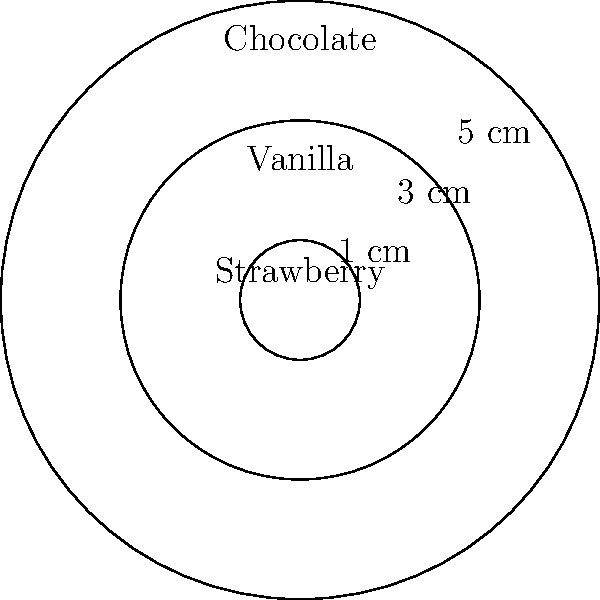You're designing a circular cake with three concentric rings of different flavors for a client's birthday party. The outer ring is chocolate, the middle ring is vanilla, and the center is strawberry. The cake has a total radius of 5 cm, with the vanilla ring starting at 3 cm from the center, and the strawberry center having a radius of 1 cm. What is the difference in area between the chocolate and vanilla sections of the cake? Let's approach this step-by-step:

1) First, we need to calculate the areas of the different sections:

   Chocolate section: Area of 5 cm circle minus area of 3 cm circle
   Vanilla section: Area of 3 cm circle minus area of 1 cm circle
   Strawberry section: Area of 1 cm circle

2) The formula for the area of a circle is $A = \pi r^2$

3) Let's calculate each area:

   Total cake area: $A_1 = \pi (5^2) = 25\pi$ cm²
   Area up to vanilla: $A_2 = \pi (3^2) = 9\pi$ cm²
   Strawberry area: $A_3 = \pi (1^2) = \pi$ cm²

4) Now we can calculate the areas of chocolate and vanilla sections:

   Chocolate area: $A_1 - A_2 = 25\pi - 9\pi = 16\pi$ cm²
   Vanilla area: $A_2 - A_3 = 9\pi - \pi = 8\pi$ cm²

5) The difference in area is:

   $16\pi - 8\pi = 8\pi$ cm²

Therefore, the chocolate section is $8\pi$ cm² larger than the vanilla section.
Answer: $8\pi$ cm² 